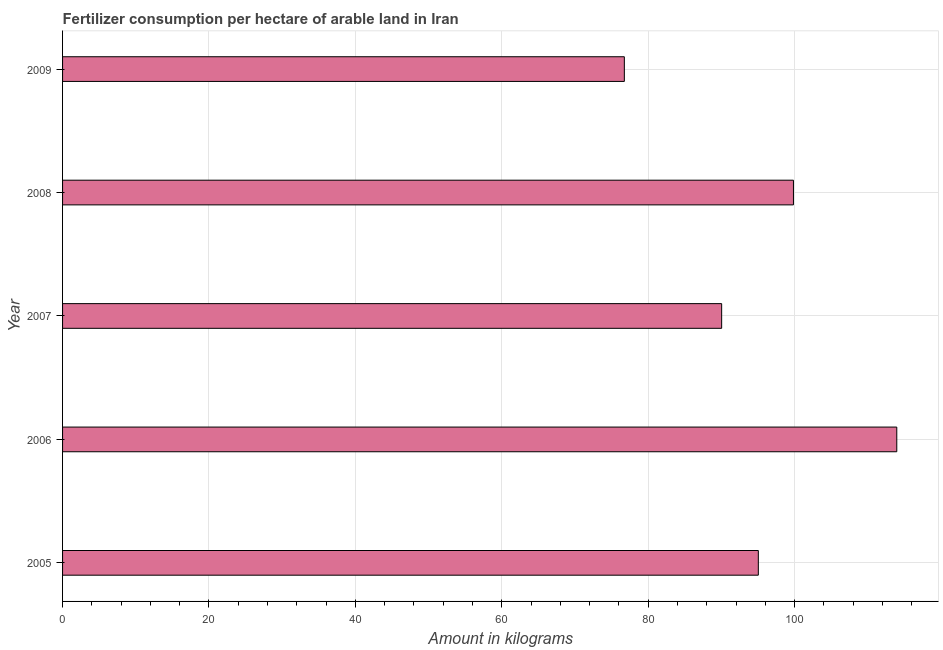Does the graph contain grids?
Provide a succinct answer. Yes. What is the title of the graph?
Your answer should be compact. Fertilizer consumption per hectare of arable land in Iran . What is the label or title of the X-axis?
Provide a succinct answer. Amount in kilograms. What is the amount of fertilizer consumption in 2005?
Your answer should be very brief. 95.05. Across all years, what is the maximum amount of fertilizer consumption?
Offer a very short reply. 113.96. Across all years, what is the minimum amount of fertilizer consumption?
Your answer should be very brief. 76.74. What is the sum of the amount of fertilizer consumption?
Your answer should be compact. 475.64. What is the difference between the amount of fertilizer consumption in 2005 and 2006?
Your response must be concise. -18.91. What is the average amount of fertilizer consumption per year?
Your response must be concise. 95.13. What is the median amount of fertilizer consumption?
Offer a terse response. 95.05. In how many years, is the amount of fertilizer consumption greater than 20 kg?
Your answer should be very brief. 5. Do a majority of the years between 2006 and 2005 (inclusive) have amount of fertilizer consumption greater than 88 kg?
Keep it short and to the point. No. What is the ratio of the amount of fertilizer consumption in 2006 to that in 2008?
Offer a very short reply. 1.14. What is the difference between the highest and the second highest amount of fertilizer consumption?
Give a very brief answer. 14.12. Is the sum of the amount of fertilizer consumption in 2008 and 2009 greater than the maximum amount of fertilizer consumption across all years?
Offer a very short reply. Yes. What is the difference between the highest and the lowest amount of fertilizer consumption?
Give a very brief answer. 37.22. In how many years, is the amount of fertilizer consumption greater than the average amount of fertilizer consumption taken over all years?
Your answer should be compact. 2. How many years are there in the graph?
Offer a very short reply. 5. What is the Amount in kilograms in 2005?
Offer a terse response. 95.05. What is the Amount in kilograms in 2006?
Make the answer very short. 113.96. What is the Amount in kilograms in 2007?
Ensure brevity in your answer.  90.04. What is the Amount in kilograms in 2008?
Ensure brevity in your answer.  99.85. What is the Amount in kilograms of 2009?
Your answer should be very brief. 76.74. What is the difference between the Amount in kilograms in 2005 and 2006?
Your response must be concise. -18.91. What is the difference between the Amount in kilograms in 2005 and 2007?
Ensure brevity in your answer.  5.01. What is the difference between the Amount in kilograms in 2005 and 2008?
Give a very brief answer. -4.8. What is the difference between the Amount in kilograms in 2005 and 2009?
Your response must be concise. 18.3. What is the difference between the Amount in kilograms in 2006 and 2007?
Your answer should be compact. 23.92. What is the difference between the Amount in kilograms in 2006 and 2008?
Give a very brief answer. 14.11. What is the difference between the Amount in kilograms in 2006 and 2009?
Your answer should be very brief. 37.22. What is the difference between the Amount in kilograms in 2007 and 2008?
Your answer should be very brief. -9.81. What is the difference between the Amount in kilograms in 2007 and 2009?
Offer a terse response. 13.29. What is the difference between the Amount in kilograms in 2008 and 2009?
Make the answer very short. 23.1. What is the ratio of the Amount in kilograms in 2005 to that in 2006?
Give a very brief answer. 0.83. What is the ratio of the Amount in kilograms in 2005 to that in 2007?
Offer a terse response. 1.06. What is the ratio of the Amount in kilograms in 2005 to that in 2009?
Offer a terse response. 1.24. What is the ratio of the Amount in kilograms in 2006 to that in 2007?
Your response must be concise. 1.27. What is the ratio of the Amount in kilograms in 2006 to that in 2008?
Provide a succinct answer. 1.14. What is the ratio of the Amount in kilograms in 2006 to that in 2009?
Your answer should be compact. 1.49. What is the ratio of the Amount in kilograms in 2007 to that in 2008?
Your answer should be very brief. 0.9. What is the ratio of the Amount in kilograms in 2007 to that in 2009?
Offer a very short reply. 1.17. What is the ratio of the Amount in kilograms in 2008 to that in 2009?
Your answer should be compact. 1.3. 